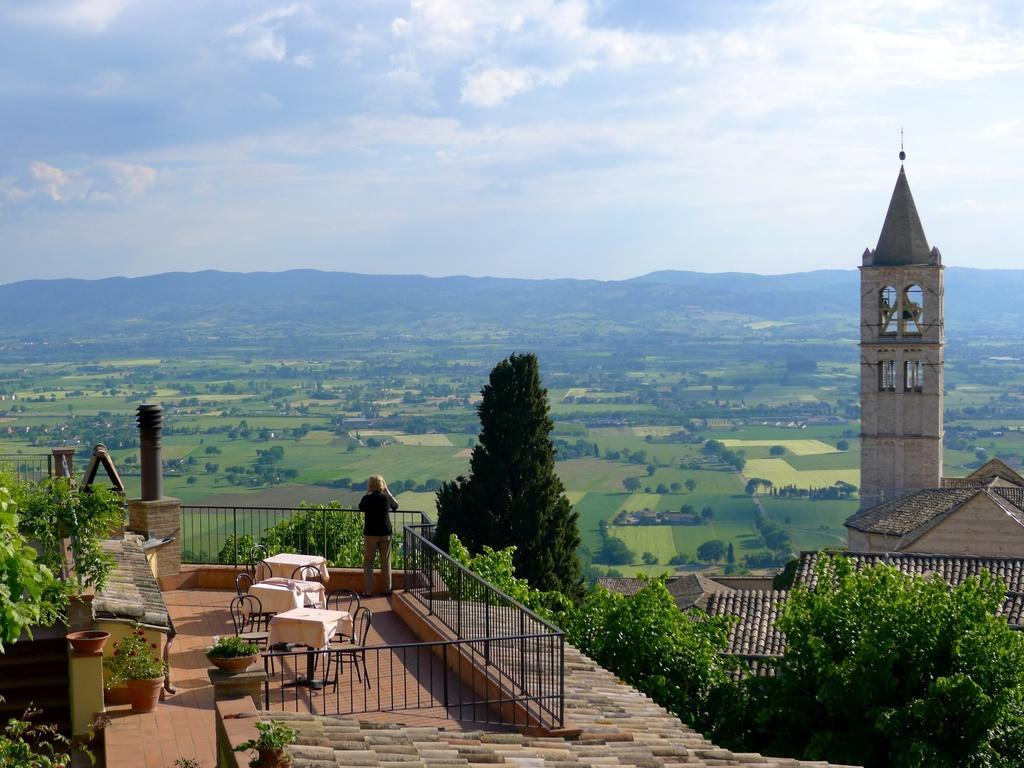Could you give a brief overview of what you see in this image? This is an aerial view where we can see buildings, trees, fields, mountains and the sky with some clouds. On the left side of the image, we can see tables, chairs, potted plants, railing and a person. 